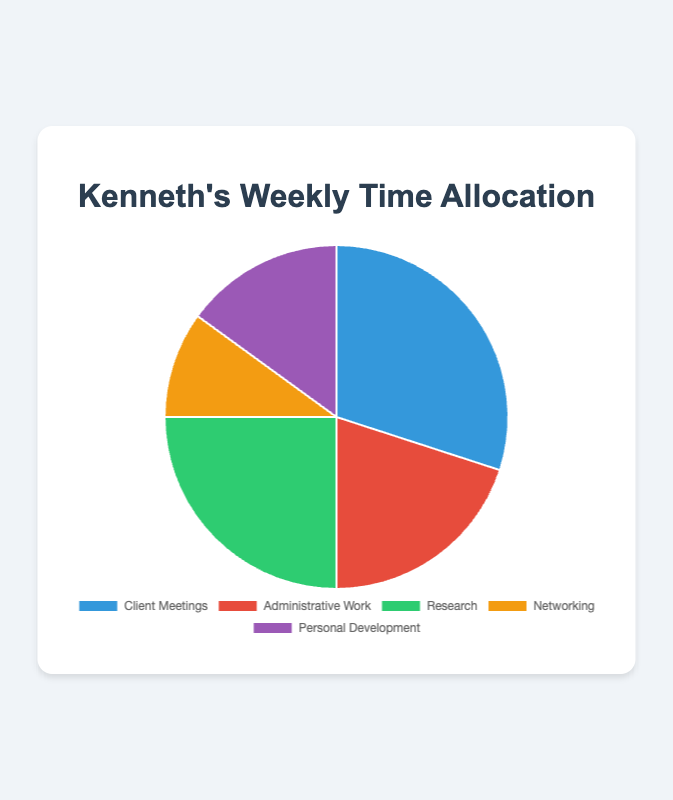What is the percentage of time spent on Research compared to Networking? Research takes up 25% of the time, while Networking takes 10%. The difference is 25% - 10% = 15%.
Answer: 15% Which task takes up the most time? Client Meetings take up the highest percentage of time at 30%.
Answer: Client Meetings What is the combined percentage of time spent on Administrative Work and Personal Development? Administrative Work is 20% and Personal Development is 15%. Combined, this sums up to 20% + 15% = 35%.
Answer: 35% How does the time spent on Client Meetings compare to the time spent on Administrative Work and Personal Development combined? Client Meetings take up 30%, while Administrative Work and Personal Development together take 35%. Thus, Client Meetings take 5% less time.
Answer: 5% less What is the average percentage of time spent on the various professional tasks? Sum all percentages (30+20+25+10+15) and divide by the number of tasks (5). The average is (100/5) = 20%.
Answer: 20% What is the visual color representation for Personal Development? Personal Development is represented by a purple color in the pie chart.
Answer: Purple If you combine the percentages of time for Client Meetings and Research, how do they compare to the total time spent on Networking and Administrative Work? Client Meetings and Research together take 30% + 25% = 55%. Networking and Administrative Work together take 10% + 20% = 30%. Hence, Client Meetings and Research take 25% more time.
Answer: 25% more Is the percentage of time spent on Research closer to Client Meetings or Administrative Work? Research takes 25% of the time. Client Meetings are at 30% and Administrative Work is at 20%. It is equally close to both, differing by 5%.
Answer: Equally close Which task has the least time allocation, and what is its percentage? Networking has the least time allocation at 10%.
Answer: Networking, 10% What would be the effect on the average if the time spent on Networking increased by 10%? If Networking increased by 10%, it would become 20%, making the total 110%. The new average would be 110% / 5 = 22%.
Answer: 22% 